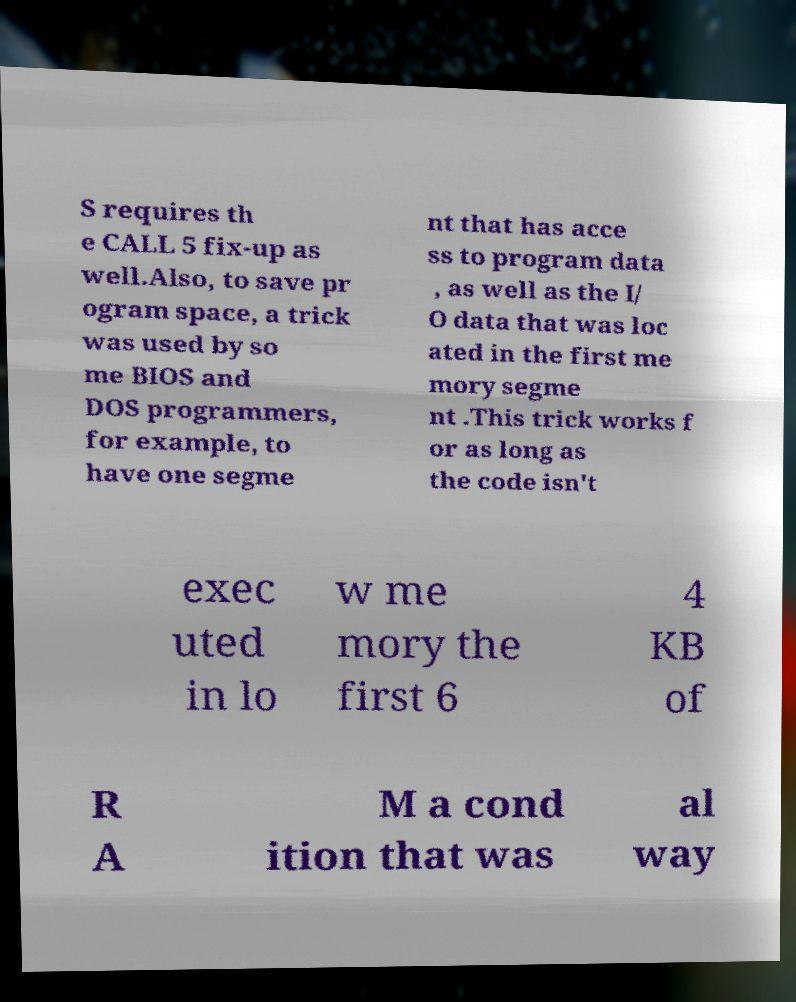I need the written content from this picture converted into text. Can you do that? S requires th e CALL 5 fix-up as well.Also, to save pr ogram space, a trick was used by so me BIOS and DOS programmers, for example, to have one segme nt that has acce ss to program data , as well as the I/ O data that was loc ated in the first me mory segme nt .This trick works f or as long as the code isn't exec uted in lo w me mory the first 6 4 KB of R A M a cond ition that was al way 